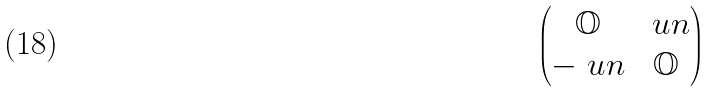<formula> <loc_0><loc_0><loc_500><loc_500>\begin{pmatrix} { \mathbb { O } } & \ u n \\ - \ u n & { \mathbb { O } } \end{pmatrix}</formula> 